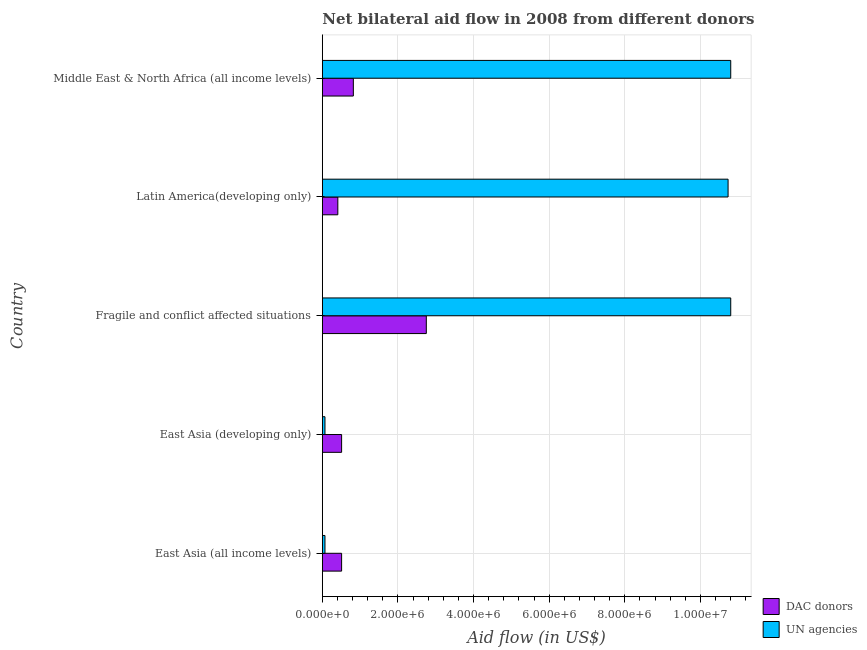Are the number of bars per tick equal to the number of legend labels?
Provide a short and direct response. Yes. Are the number of bars on each tick of the Y-axis equal?
Your answer should be compact. Yes. How many bars are there on the 4th tick from the top?
Your answer should be very brief. 2. How many bars are there on the 1st tick from the bottom?
Provide a succinct answer. 2. What is the label of the 4th group of bars from the top?
Give a very brief answer. East Asia (developing only). What is the aid flow from dac donors in East Asia (all income levels)?
Provide a short and direct response. 5.10e+05. Across all countries, what is the maximum aid flow from un agencies?
Offer a very short reply. 1.08e+07. Across all countries, what is the minimum aid flow from un agencies?
Your response must be concise. 7.00e+04. In which country was the aid flow from un agencies maximum?
Provide a succinct answer. Fragile and conflict affected situations. In which country was the aid flow from dac donors minimum?
Make the answer very short. Latin America(developing only). What is the total aid flow from dac donors in the graph?
Your response must be concise. 5.00e+06. What is the difference between the aid flow from un agencies in Latin America(developing only) and that in Middle East & North Africa (all income levels)?
Your answer should be compact. -7.00e+04. What is the difference between the aid flow from un agencies in East Asia (all income levels) and the aid flow from dac donors in Middle East & North Africa (all income levels)?
Offer a very short reply. -7.50e+05. What is the average aid flow from un agencies per country?
Make the answer very short. 6.49e+06. What is the difference between the aid flow from un agencies and aid flow from dac donors in Fragile and conflict affected situations?
Your response must be concise. 8.05e+06. What is the ratio of the aid flow from un agencies in East Asia (all income levels) to that in Middle East & North Africa (all income levels)?
Provide a short and direct response. 0.01. What is the difference between the highest and the second highest aid flow from dac donors?
Provide a succinct answer. 1.93e+06. What is the difference between the highest and the lowest aid flow from dac donors?
Offer a very short reply. 2.34e+06. What does the 2nd bar from the top in Fragile and conflict affected situations represents?
Provide a succinct answer. DAC donors. What does the 1st bar from the bottom in East Asia (developing only) represents?
Ensure brevity in your answer.  DAC donors. How many bars are there?
Keep it short and to the point. 10. Are all the bars in the graph horizontal?
Offer a very short reply. Yes. How many countries are there in the graph?
Your answer should be very brief. 5. Are the values on the major ticks of X-axis written in scientific E-notation?
Give a very brief answer. Yes. Does the graph contain any zero values?
Your answer should be very brief. No. How many legend labels are there?
Offer a very short reply. 2. What is the title of the graph?
Your answer should be very brief. Net bilateral aid flow in 2008 from different donors. What is the label or title of the X-axis?
Your answer should be very brief. Aid flow (in US$). What is the Aid flow (in US$) of DAC donors in East Asia (all income levels)?
Ensure brevity in your answer.  5.10e+05. What is the Aid flow (in US$) in UN agencies in East Asia (all income levels)?
Ensure brevity in your answer.  7.00e+04. What is the Aid flow (in US$) in DAC donors in East Asia (developing only)?
Make the answer very short. 5.10e+05. What is the Aid flow (in US$) of DAC donors in Fragile and conflict affected situations?
Offer a very short reply. 2.75e+06. What is the Aid flow (in US$) of UN agencies in Fragile and conflict affected situations?
Your answer should be compact. 1.08e+07. What is the Aid flow (in US$) of UN agencies in Latin America(developing only)?
Give a very brief answer. 1.07e+07. What is the Aid flow (in US$) in DAC donors in Middle East & North Africa (all income levels)?
Ensure brevity in your answer.  8.20e+05. What is the Aid flow (in US$) in UN agencies in Middle East & North Africa (all income levels)?
Provide a succinct answer. 1.08e+07. Across all countries, what is the maximum Aid flow (in US$) in DAC donors?
Offer a terse response. 2.75e+06. Across all countries, what is the maximum Aid flow (in US$) in UN agencies?
Your answer should be very brief. 1.08e+07. Across all countries, what is the minimum Aid flow (in US$) in UN agencies?
Offer a very short reply. 7.00e+04. What is the total Aid flow (in US$) of UN agencies in the graph?
Your answer should be compact. 3.25e+07. What is the difference between the Aid flow (in US$) of DAC donors in East Asia (all income levels) and that in East Asia (developing only)?
Give a very brief answer. 0. What is the difference between the Aid flow (in US$) of UN agencies in East Asia (all income levels) and that in East Asia (developing only)?
Provide a succinct answer. 0. What is the difference between the Aid flow (in US$) of DAC donors in East Asia (all income levels) and that in Fragile and conflict affected situations?
Provide a short and direct response. -2.24e+06. What is the difference between the Aid flow (in US$) of UN agencies in East Asia (all income levels) and that in Fragile and conflict affected situations?
Keep it short and to the point. -1.07e+07. What is the difference between the Aid flow (in US$) of UN agencies in East Asia (all income levels) and that in Latin America(developing only)?
Give a very brief answer. -1.07e+07. What is the difference between the Aid flow (in US$) of DAC donors in East Asia (all income levels) and that in Middle East & North Africa (all income levels)?
Give a very brief answer. -3.10e+05. What is the difference between the Aid flow (in US$) in UN agencies in East Asia (all income levels) and that in Middle East & North Africa (all income levels)?
Ensure brevity in your answer.  -1.07e+07. What is the difference between the Aid flow (in US$) in DAC donors in East Asia (developing only) and that in Fragile and conflict affected situations?
Your response must be concise. -2.24e+06. What is the difference between the Aid flow (in US$) of UN agencies in East Asia (developing only) and that in Fragile and conflict affected situations?
Give a very brief answer. -1.07e+07. What is the difference between the Aid flow (in US$) of UN agencies in East Asia (developing only) and that in Latin America(developing only)?
Provide a short and direct response. -1.07e+07. What is the difference between the Aid flow (in US$) of DAC donors in East Asia (developing only) and that in Middle East & North Africa (all income levels)?
Your response must be concise. -3.10e+05. What is the difference between the Aid flow (in US$) in UN agencies in East Asia (developing only) and that in Middle East & North Africa (all income levels)?
Your answer should be very brief. -1.07e+07. What is the difference between the Aid flow (in US$) of DAC donors in Fragile and conflict affected situations and that in Latin America(developing only)?
Your answer should be compact. 2.34e+06. What is the difference between the Aid flow (in US$) of UN agencies in Fragile and conflict affected situations and that in Latin America(developing only)?
Provide a short and direct response. 7.00e+04. What is the difference between the Aid flow (in US$) of DAC donors in Fragile and conflict affected situations and that in Middle East & North Africa (all income levels)?
Offer a terse response. 1.93e+06. What is the difference between the Aid flow (in US$) of UN agencies in Fragile and conflict affected situations and that in Middle East & North Africa (all income levels)?
Offer a very short reply. 0. What is the difference between the Aid flow (in US$) of DAC donors in Latin America(developing only) and that in Middle East & North Africa (all income levels)?
Your answer should be very brief. -4.10e+05. What is the difference between the Aid flow (in US$) of UN agencies in Latin America(developing only) and that in Middle East & North Africa (all income levels)?
Your answer should be very brief. -7.00e+04. What is the difference between the Aid flow (in US$) in DAC donors in East Asia (all income levels) and the Aid flow (in US$) in UN agencies in Fragile and conflict affected situations?
Ensure brevity in your answer.  -1.03e+07. What is the difference between the Aid flow (in US$) in DAC donors in East Asia (all income levels) and the Aid flow (in US$) in UN agencies in Latin America(developing only)?
Ensure brevity in your answer.  -1.02e+07. What is the difference between the Aid flow (in US$) in DAC donors in East Asia (all income levels) and the Aid flow (in US$) in UN agencies in Middle East & North Africa (all income levels)?
Offer a very short reply. -1.03e+07. What is the difference between the Aid flow (in US$) in DAC donors in East Asia (developing only) and the Aid flow (in US$) in UN agencies in Fragile and conflict affected situations?
Provide a short and direct response. -1.03e+07. What is the difference between the Aid flow (in US$) of DAC donors in East Asia (developing only) and the Aid flow (in US$) of UN agencies in Latin America(developing only)?
Your response must be concise. -1.02e+07. What is the difference between the Aid flow (in US$) in DAC donors in East Asia (developing only) and the Aid flow (in US$) in UN agencies in Middle East & North Africa (all income levels)?
Your answer should be compact. -1.03e+07. What is the difference between the Aid flow (in US$) in DAC donors in Fragile and conflict affected situations and the Aid flow (in US$) in UN agencies in Latin America(developing only)?
Give a very brief answer. -7.98e+06. What is the difference between the Aid flow (in US$) in DAC donors in Fragile and conflict affected situations and the Aid flow (in US$) in UN agencies in Middle East & North Africa (all income levels)?
Offer a terse response. -8.05e+06. What is the difference between the Aid flow (in US$) of DAC donors in Latin America(developing only) and the Aid flow (in US$) of UN agencies in Middle East & North Africa (all income levels)?
Give a very brief answer. -1.04e+07. What is the average Aid flow (in US$) of UN agencies per country?
Give a very brief answer. 6.49e+06. What is the difference between the Aid flow (in US$) of DAC donors and Aid flow (in US$) of UN agencies in Fragile and conflict affected situations?
Provide a succinct answer. -8.05e+06. What is the difference between the Aid flow (in US$) in DAC donors and Aid flow (in US$) in UN agencies in Latin America(developing only)?
Offer a very short reply. -1.03e+07. What is the difference between the Aid flow (in US$) of DAC donors and Aid flow (in US$) of UN agencies in Middle East & North Africa (all income levels)?
Provide a short and direct response. -9.98e+06. What is the ratio of the Aid flow (in US$) of UN agencies in East Asia (all income levels) to that in East Asia (developing only)?
Provide a succinct answer. 1. What is the ratio of the Aid flow (in US$) of DAC donors in East Asia (all income levels) to that in Fragile and conflict affected situations?
Offer a terse response. 0.19. What is the ratio of the Aid flow (in US$) in UN agencies in East Asia (all income levels) to that in Fragile and conflict affected situations?
Offer a terse response. 0.01. What is the ratio of the Aid flow (in US$) of DAC donors in East Asia (all income levels) to that in Latin America(developing only)?
Provide a succinct answer. 1.24. What is the ratio of the Aid flow (in US$) of UN agencies in East Asia (all income levels) to that in Latin America(developing only)?
Ensure brevity in your answer.  0.01. What is the ratio of the Aid flow (in US$) in DAC donors in East Asia (all income levels) to that in Middle East & North Africa (all income levels)?
Provide a short and direct response. 0.62. What is the ratio of the Aid flow (in US$) in UN agencies in East Asia (all income levels) to that in Middle East & North Africa (all income levels)?
Keep it short and to the point. 0.01. What is the ratio of the Aid flow (in US$) of DAC donors in East Asia (developing only) to that in Fragile and conflict affected situations?
Provide a short and direct response. 0.19. What is the ratio of the Aid flow (in US$) in UN agencies in East Asia (developing only) to that in Fragile and conflict affected situations?
Keep it short and to the point. 0.01. What is the ratio of the Aid flow (in US$) in DAC donors in East Asia (developing only) to that in Latin America(developing only)?
Your answer should be compact. 1.24. What is the ratio of the Aid flow (in US$) in UN agencies in East Asia (developing only) to that in Latin America(developing only)?
Your response must be concise. 0.01. What is the ratio of the Aid flow (in US$) in DAC donors in East Asia (developing only) to that in Middle East & North Africa (all income levels)?
Your answer should be compact. 0.62. What is the ratio of the Aid flow (in US$) in UN agencies in East Asia (developing only) to that in Middle East & North Africa (all income levels)?
Make the answer very short. 0.01. What is the ratio of the Aid flow (in US$) in DAC donors in Fragile and conflict affected situations to that in Latin America(developing only)?
Your response must be concise. 6.71. What is the ratio of the Aid flow (in US$) of DAC donors in Fragile and conflict affected situations to that in Middle East & North Africa (all income levels)?
Ensure brevity in your answer.  3.35. What is the ratio of the Aid flow (in US$) in DAC donors in Latin America(developing only) to that in Middle East & North Africa (all income levels)?
Your answer should be very brief. 0.5. What is the difference between the highest and the second highest Aid flow (in US$) of DAC donors?
Give a very brief answer. 1.93e+06. What is the difference between the highest and the lowest Aid flow (in US$) of DAC donors?
Your response must be concise. 2.34e+06. What is the difference between the highest and the lowest Aid flow (in US$) in UN agencies?
Offer a terse response. 1.07e+07. 